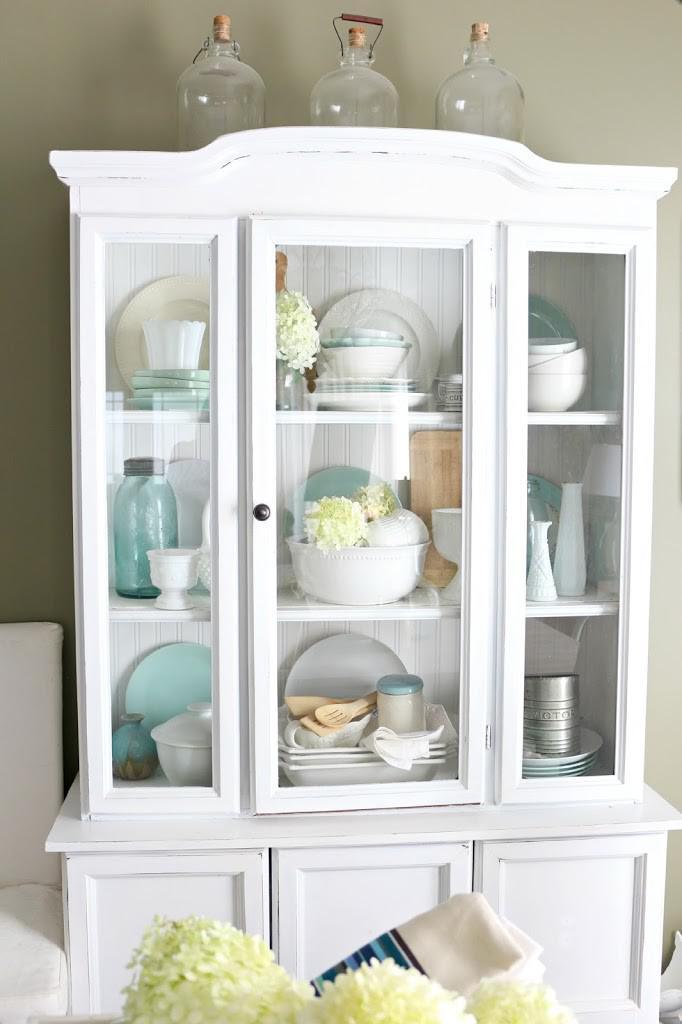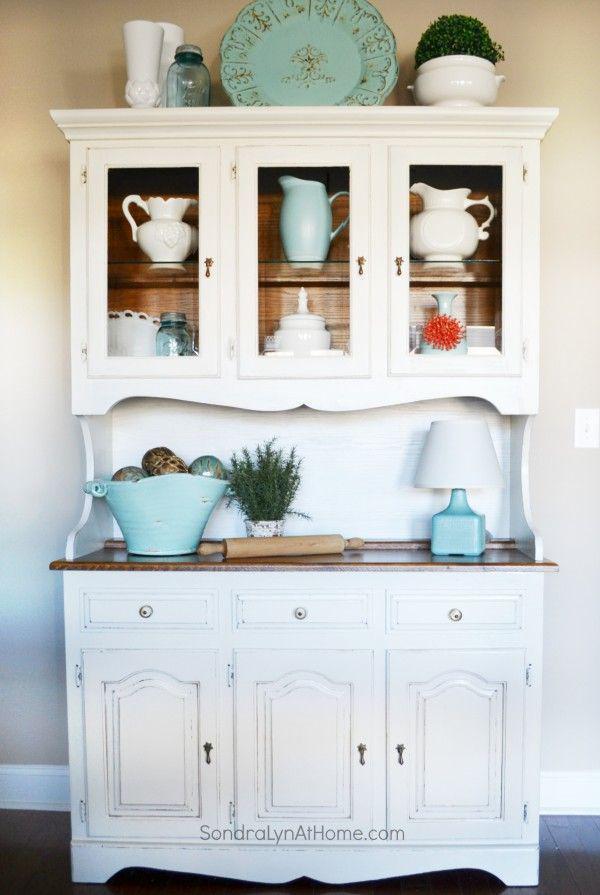The first image is the image on the left, the second image is the image on the right. Examine the images to the left and right. Is the description "Within the china cabinet, one of the cabinet's inner walls have been painted green, but not blue." accurate? Answer yes or no. No. The first image is the image on the left, the second image is the image on the right. For the images displayed, is the sentence "At least one cabinet has a non-flat top with nothing perched above it, and a bottom that lacks any scrollwork." factually correct? Answer yes or no. No. 